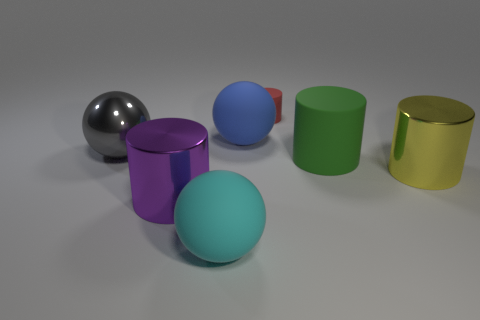Subtract all cyan spheres. How many spheres are left? 2 Add 1 small gray things. How many objects exist? 8 Subtract all yellow cylinders. How many cylinders are left? 3 Subtract 3 balls. How many balls are left? 0 Subtract all spheres. How many objects are left? 4 Add 7 big yellow cylinders. How many big yellow cylinders exist? 8 Subtract 0 yellow cubes. How many objects are left? 7 Subtract all brown balls. Subtract all green blocks. How many balls are left? 3 Subtract all big gray shiny balls. Subtract all red cubes. How many objects are left? 6 Add 4 big matte cylinders. How many big matte cylinders are left? 5 